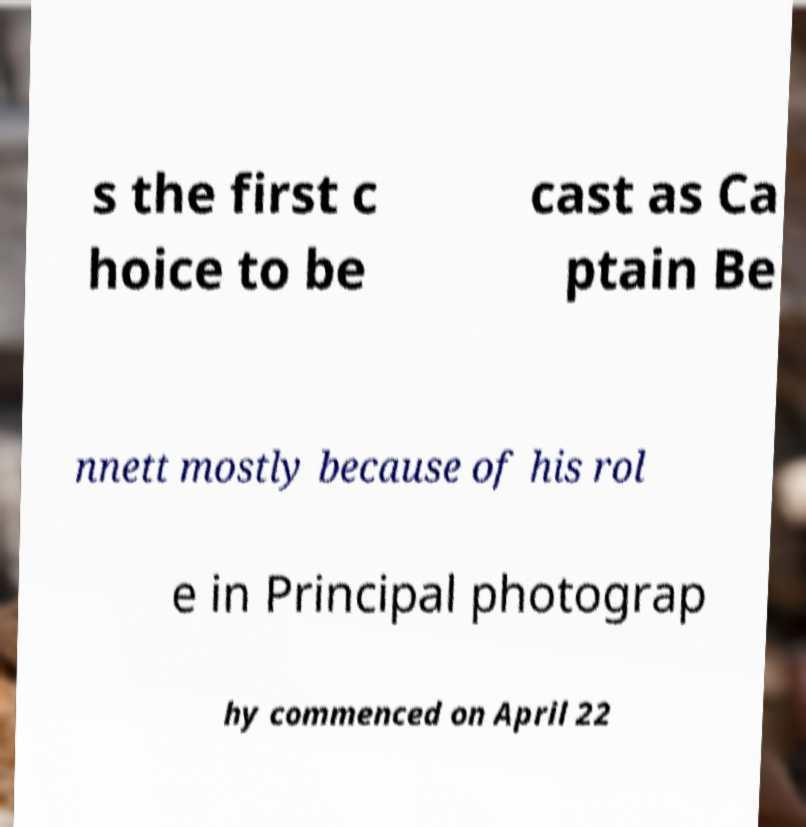Can you read and provide the text displayed in the image?This photo seems to have some interesting text. Can you extract and type it out for me? s the first c hoice to be cast as Ca ptain Be nnett mostly because of his rol e in Principal photograp hy commenced on April 22 